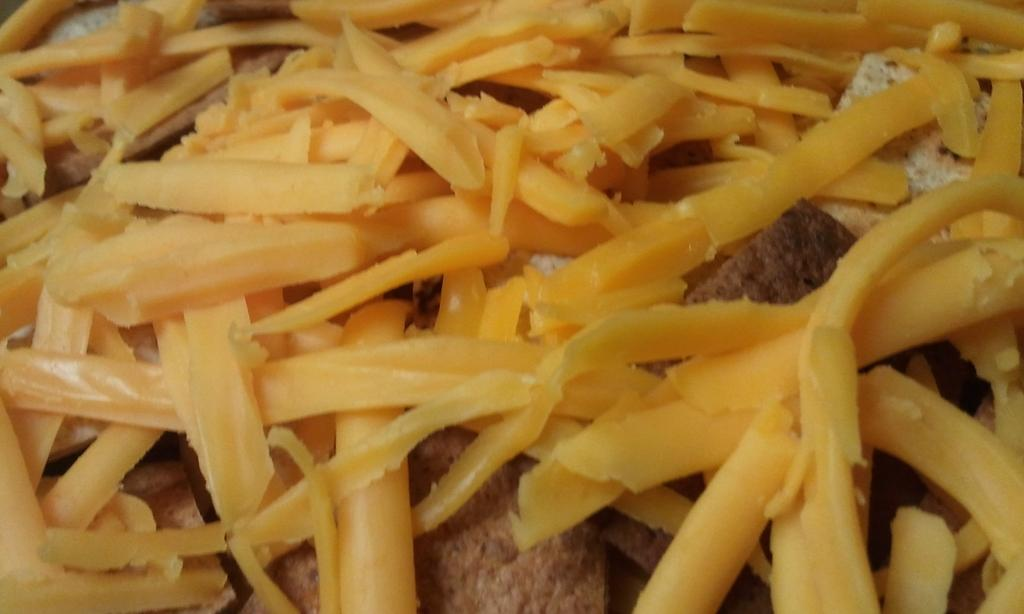What type of items can be seen in the image? There are food items in the image. How many apples can be seen being bitten into in the image? There is no indication of apples or any items being bitten into in the image. 